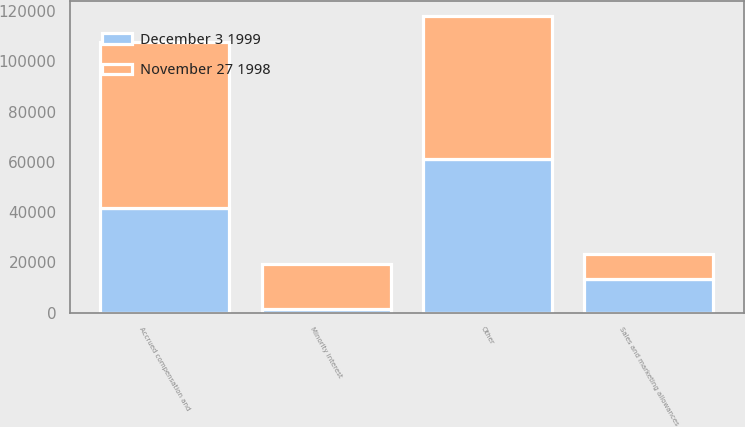<chart> <loc_0><loc_0><loc_500><loc_500><stacked_bar_chart><ecel><fcel>Accrued compensation and<fcel>Sales and marketing allowances<fcel>Minority interest<fcel>Other<nl><fcel>November 27 1998<fcel>65957<fcel>9990<fcel>17737<fcel>57218<nl><fcel>December 3 1999<fcel>41592<fcel>13439<fcel>1525<fcel>60983<nl></chart> 